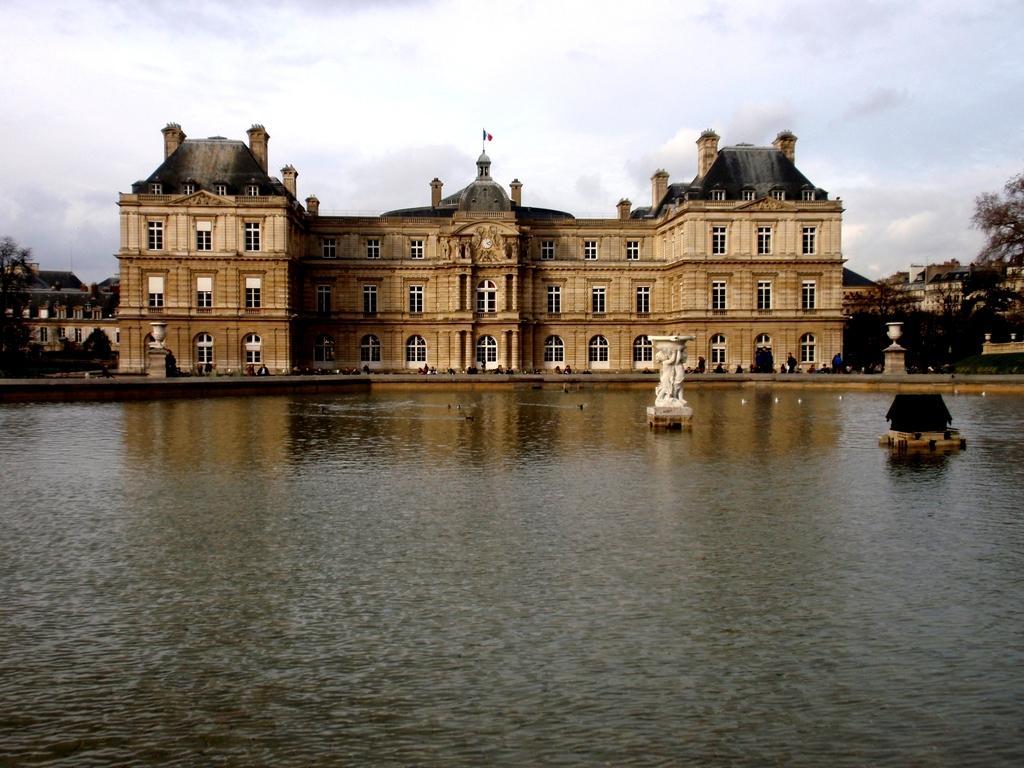How would you summarize this image in a sentence or two? In the center of the image there is a palace. At the bottom of the image there is water. At the top of the image there are clouds. At the background of the image there are trees. 